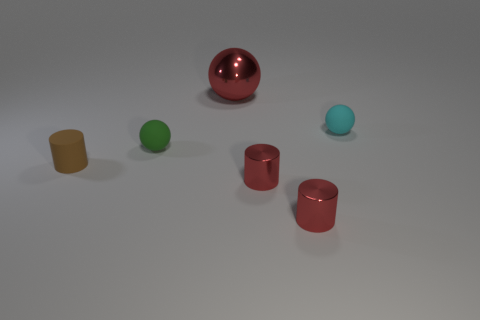Add 1 shiny cylinders. How many objects exist? 7 Subtract all red cylinders. How many cylinders are left? 1 Subtract all red cylinders. How many cylinders are left? 1 Subtract 0 purple balls. How many objects are left? 6 Subtract 1 cylinders. How many cylinders are left? 2 Subtract all yellow cylinders. Subtract all green balls. How many cylinders are left? 3 Subtract all green cubes. How many red cylinders are left? 2 Subtract all gray metal cubes. Subtract all matte balls. How many objects are left? 4 Add 4 small brown rubber cylinders. How many small brown rubber cylinders are left? 5 Add 1 green things. How many green things exist? 2 